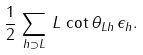<formula> <loc_0><loc_0><loc_500><loc_500>\frac { 1 } { 2 } \, \sum _ { h \supset L } \, L \, \cot { \theta _ { L h } } \, \epsilon _ { h } .</formula> 